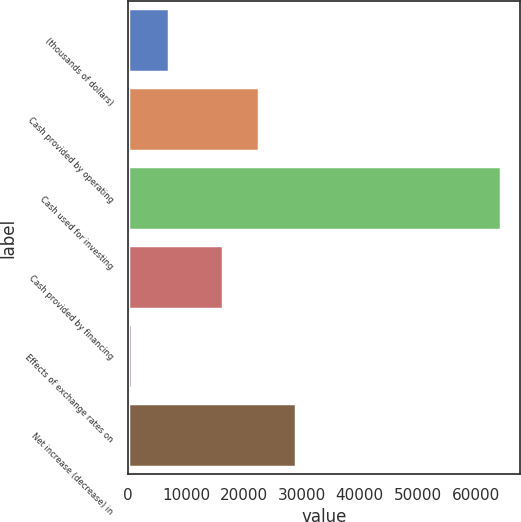Convert chart. <chart><loc_0><loc_0><loc_500><loc_500><bar_chart><fcel>(thousands of dollars)<fcel>Cash provided by operating<fcel>Cash used for investing<fcel>Cash provided by financing<fcel>Effects of exchange rates on<fcel>Net increase (decrease) in<nl><fcel>7101.9<fcel>22683.9<fcel>64422<fcel>16315<fcel>733<fcel>29052.8<nl></chart> 